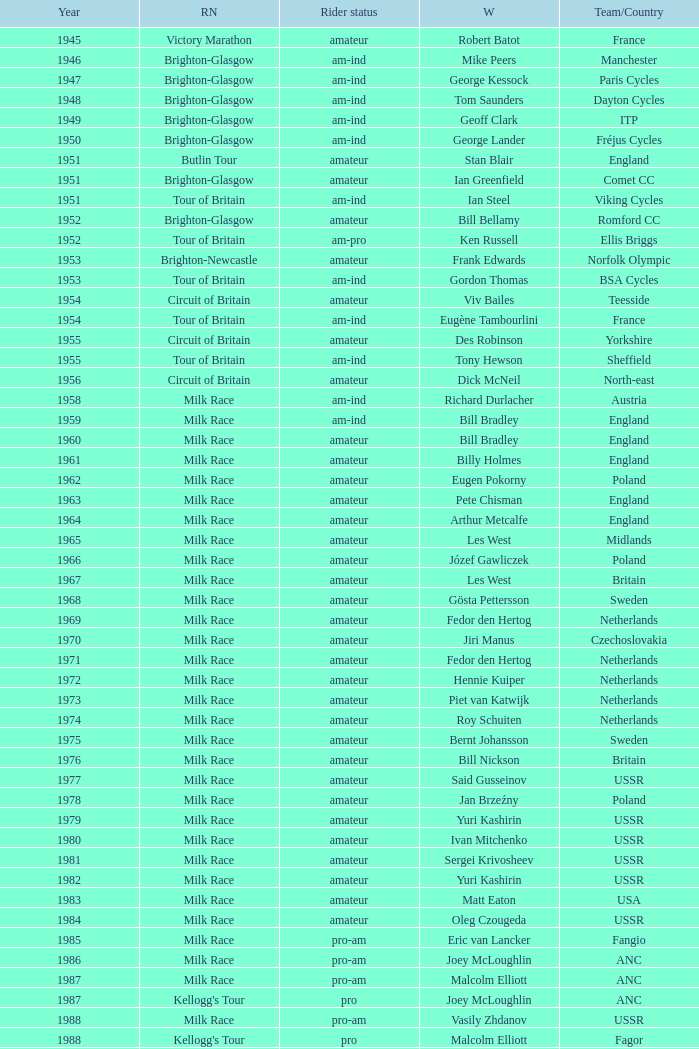Who was the winner in 1973 with an amateur rider status? Piet van Katwijk. 